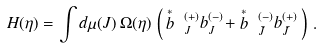Convert formula to latex. <formula><loc_0><loc_0><loc_500><loc_500>H ( \eta ) = \int d \mu ( J ) \, \Omega ( \eta ) \, \left ( \, \stackrel { * } { b } \, { \, } ^ { ( + ) } _ { J } b ^ { ( - ) } _ { J } + \stackrel { * } { b } \, { \, } ^ { ( - ) } _ { \bar { J } } b ^ { ( + ) } _ { \bar { J } } \, \right ) \, .</formula> 